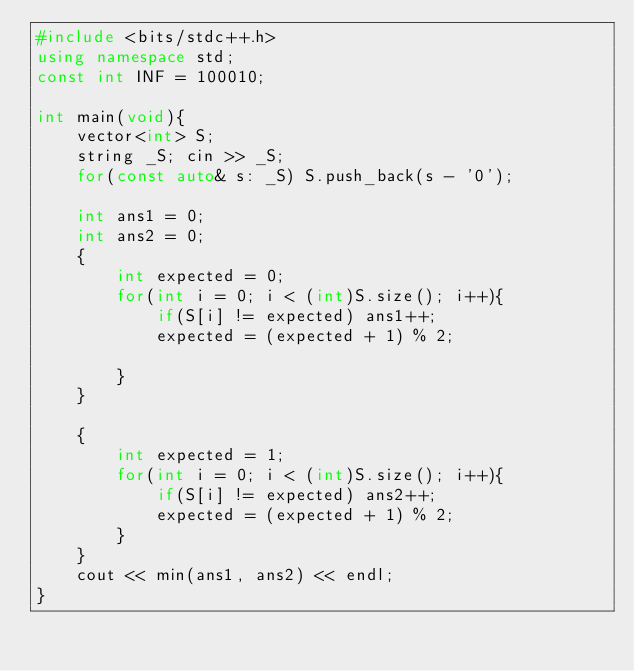Convert code to text. <code><loc_0><loc_0><loc_500><loc_500><_C++_>#include <bits/stdc++.h>
using namespace std;
const int INF = 100010;

int main(void){
    vector<int> S;
    string _S; cin >> _S;
    for(const auto& s: _S) S.push_back(s - '0');

    int ans1 = 0;
    int ans2 = 0;
    {
        int expected = 0;
        for(int i = 0; i < (int)S.size(); i++){
            if(S[i] != expected) ans1++;
            expected = (expected + 1) % 2;

        }
    }

    {
        int expected = 1;
        for(int i = 0; i < (int)S.size(); i++){
            if(S[i] != expected) ans2++;
            expected = (expected + 1) % 2;
        }
    }
    cout << min(ans1, ans2) << endl;
}</code> 